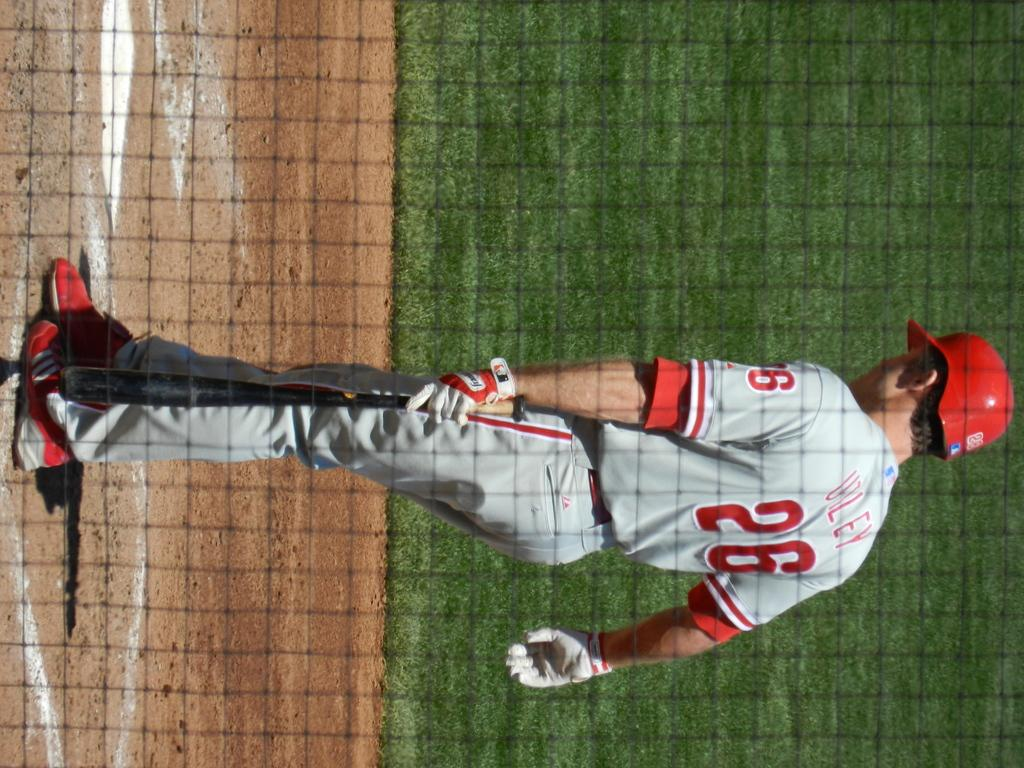What is the orientation of the image? The image is vertical. Who or what is the main subject in the image? There is a person in the image. What is the person wearing on their upper body? The person is wearing a grey jersey. What type of headwear is the person wearing? The person is wearing a red cap. What type of footwear is the person wearing? The person is wearing red shoes. What type of terrain is visible in the image? There is land in the image. What type of vegetation can be seen in the background? There is grassland in the background. What object is present in the front of the image? There is a net in the front of the image. What type of brick is being used to build the fireman's house in the image? There is no fireman or brick house present in the image. How does the sleet affect the person's ability to play in the image? There is no mention of sleet in the image, and the person's activities are not affected by any weather conditions. 